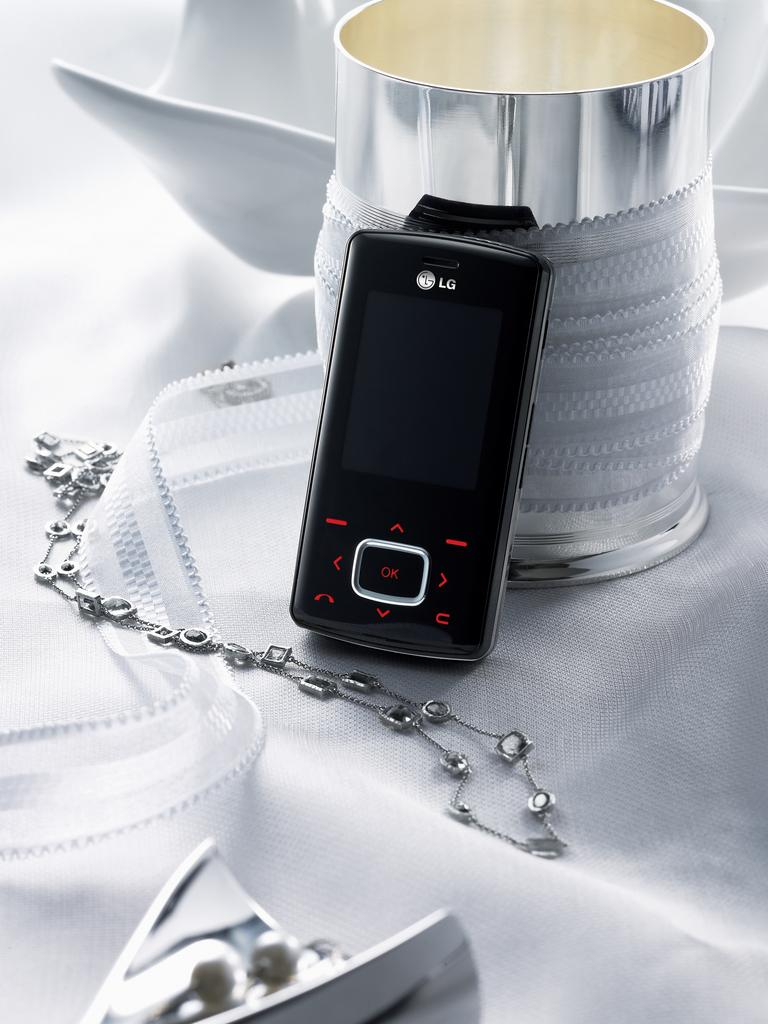What color is the cloth that is visible in the image? There is a white cloth in the image. What is placed on the white cloth? There are electronic gadgets, a chain, bowl-like things, and other objects on the white cloth. Can you see a robin perched on the chain in the image? There is no robin present in the image; it only features a white cloth with various objects on it. 